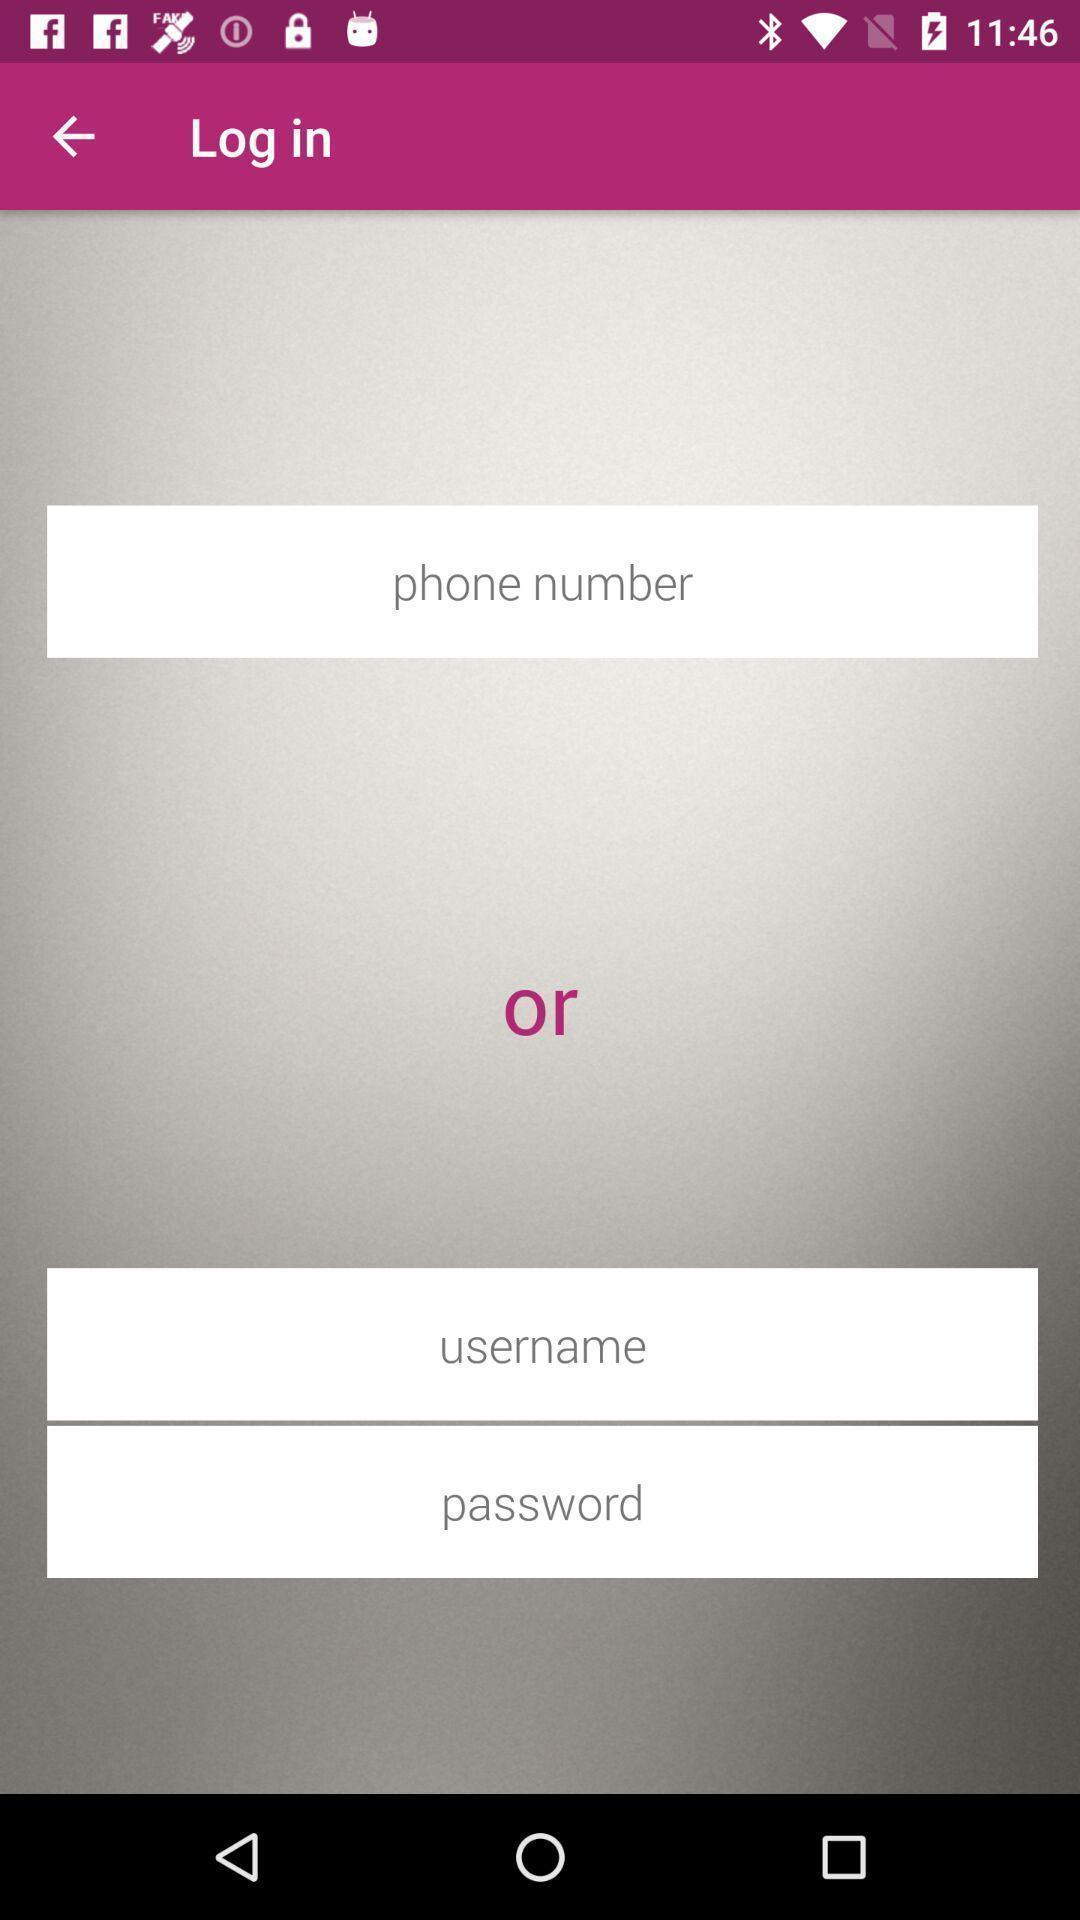Tell me what you see in this picture. Login page. 